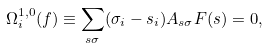Convert formula to latex. <formula><loc_0><loc_0><loc_500><loc_500>\Omega ^ { 1 , 0 } _ { i } ( f ) \equiv \sum _ { s \sigma } ( \sigma _ { i } - s _ { i } ) A _ { s \sigma } F ( s ) = 0 ,</formula> 